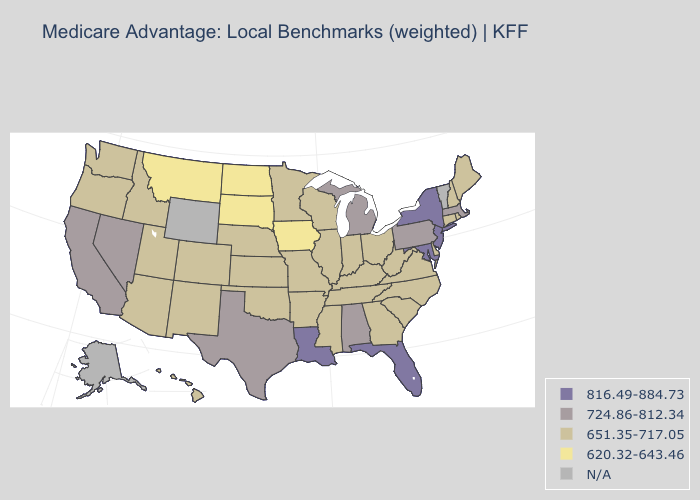Name the states that have a value in the range 651.35-717.05?
Be succinct. Arkansas, Arizona, Colorado, Connecticut, Delaware, Georgia, Hawaii, Idaho, Illinois, Indiana, Kansas, Kentucky, Maine, Minnesota, Missouri, Mississippi, North Carolina, Nebraska, New Hampshire, New Mexico, Ohio, Oklahoma, Oregon, Rhode Island, South Carolina, Tennessee, Utah, Virginia, Washington, Wisconsin, West Virginia. What is the value of Mississippi?
Give a very brief answer. 651.35-717.05. What is the highest value in states that border Nevada?
Short answer required. 724.86-812.34. Does the map have missing data?
Concise answer only. Yes. Among the states that border Arkansas , does Texas have the lowest value?
Concise answer only. No. Which states have the highest value in the USA?
Short answer required. Florida, Louisiana, Maryland, New Jersey, New York. Name the states that have a value in the range 724.86-812.34?
Keep it brief. Alabama, California, Massachusetts, Michigan, Nevada, Pennsylvania, Texas. Name the states that have a value in the range 620.32-643.46?
Keep it brief. Iowa, Montana, North Dakota, South Dakota. What is the value of Maryland?
Be succinct. 816.49-884.73. What is the value of Minnesota?
Give a very brief answer. 651.35-717.05. Name the states that have a value in the range 816.49-884.73?
Be succinct. Florida, Louisiana, Maryland, New Jersey, New York. What is the highest value in the South ?
Concise answer only. 816.49-884.73. Which states have the lowest value in the South?
Quick response, please. Arkansas, Delaware, Georgia, Kentucky, Mississippi, North Carolina, Oklahoma, South Carolina, Tennessee, Virginia, West Virginia. Does Kentucky have the highest value in the USA?
Short answer required. No. 